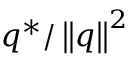Convert formula to latex. <formula><loc_0><loc_0><loc_500><loc_500>q ^ { * } / \left \| q \right \| ^ { 2 }</formula> 